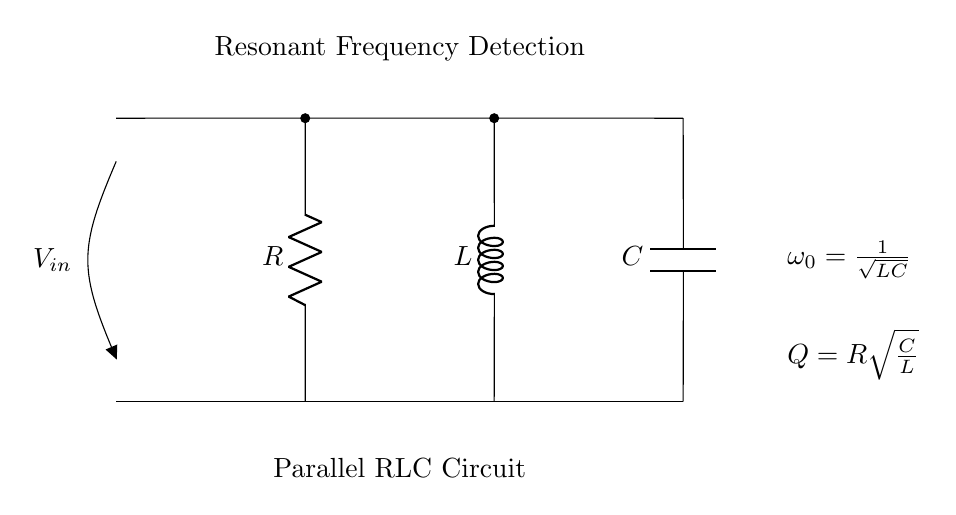What does the circuit mainly detect? The circuit is designed to detect resonant frequency, as indicated by the label "Resonant Frequency Detection." The presence of the components R, L, and C suggests that it is analyzing how they resonate together at a specific frequency.
Answer: Resonant frequency What is the formula for resonant frequency in this circuit? The formula for resonant frequency is given in the circuit as omega zero equals one over the square root of LC. This indicates how R, L, and C relate to the resonant frequency.
Answer: 1 over square root of LC What type of circuit is shown? The circuit is a parallel RLC circuit, as it explicitly shows the arrangement of the resistor, inductor, and capacitor in parallel. This information is specified both in the title and the layout of the components.
Answer: Parallel RLC circuit What does the Q factor represent in this circuit? The Q factor is shown as R times the square root of C over L. This indicates the circuit's quality factor, which relates to the bandwidth of the resonance and how underdamped the system is.
Answer: R times square root of C over L How many components are present in the circuit? There are three primary components visible: a resistor, an inductor, and a capacitor. The diagram clearly marks each component, confirming their presence in the setup.
Answer: Three components What happens to the current at resonant frequency? At the resonant frequency, the impedance is minimized, leading to maximal current flow through the circuit. The arrangement of R, L, and C at resonance causes the inductor and capacitor to cancel out their reactances, allowing current to peak.
Answer: Maximal current flow 